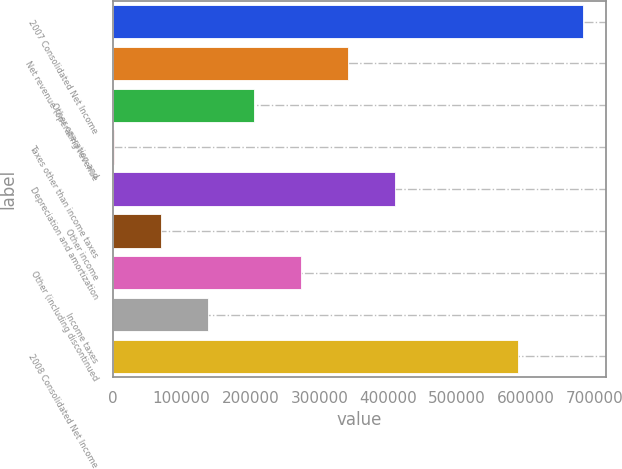<chart> <loc_0><loc_0><loc_500><loc_500><bar_chart><fcel>2007 Consolidated Net Income<fcel>Net revenue (operating revenue<fcel>Other operation and<fcel>Taxes other than income taxes<fcel>Depreciation and amortization<fcel>Other income<fcel>Other (including discontinued<fcel>Income taxes<fcel>2008 Consolidated Net Income<nl><fcel>682707<fcel>342126<fcel>205893<fcel>1544<fcel>410242<fcel>69660.3<fcel>274009<fcel>137777<fcel>587837<nl></chart> 